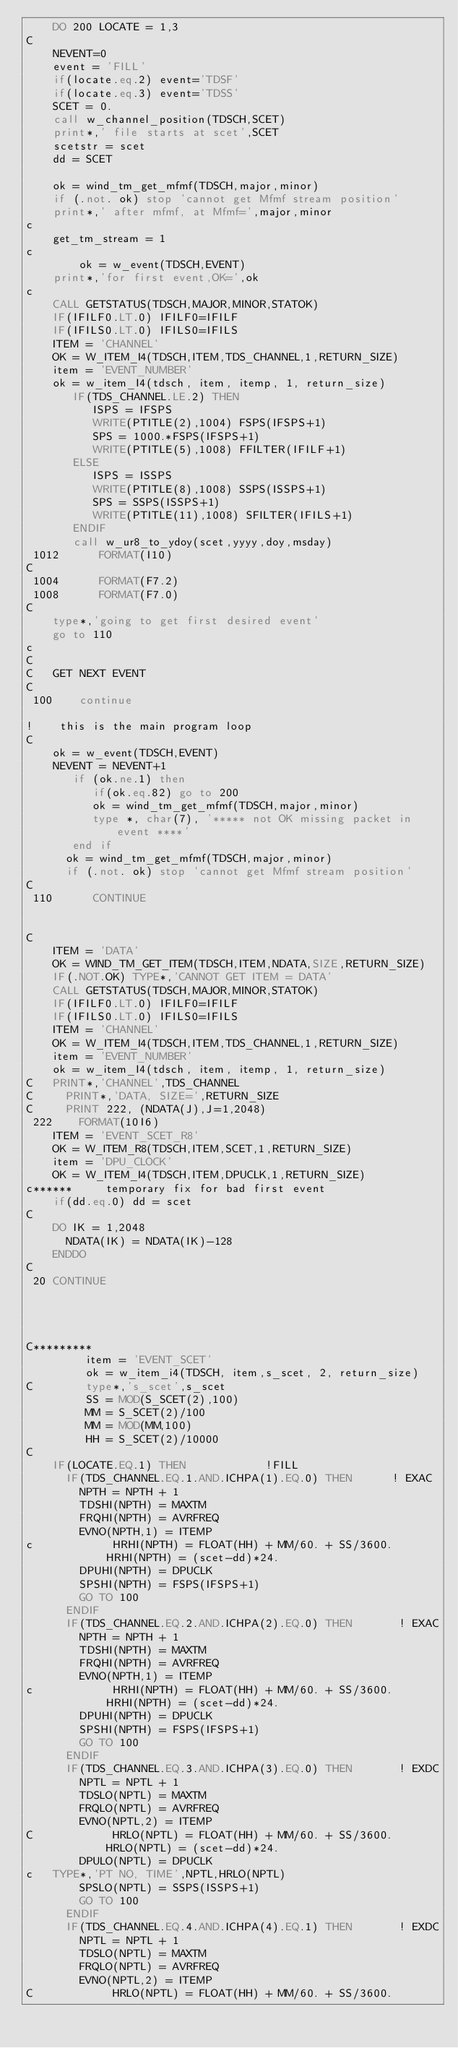Convert code to text. <code><loc_0><loc_0><loc_500><loc_500><_FORTRAN_>	DO 200 LOCATE = 1,3
C
	NEVENT=0
	event = 'FILL'
	if(locate.eq.2) event='TDSF'
	if(locate.eq.3) event='TDSS'
	SCET = 0.
	call w_channel_position(TDSCH,SCET)
	print*,' file starts at scet',SCET
	scetstr = scet
	dd = SCET

	ok = wind_tm_get_mfmf(TDSCH,major,minor)
	if (.not. ok) stop 'cannot get Mfmf stream position'
	print*,' after mfmf, at Mfmf=',major,minor
c
	get_tm_stream = 1
c
        ok = w_event(TDSCH,EVENT)
	print*,'for first event,OK=',ok
c
	CALL GETSTATUS(TDSCH,MAJOR,MINOR,STATOK)
	IF(IFILF0.LT.0) IFILF0=IFILF
	IF(IFILS0.LT.0) IFILS0=IFILS
	ITEM = 'CHANNEL'
	OK = W_ITEM_I4(TDSCH,ITEM,TDS_CHANNEL,1,RETURN_SIZE)
	item = 'EVENT_NUMBER'
	ok = w_item_I4(tdsch, item, itemp, 1, return_size)
	   IF(TDS_CHANNEL.LE.2) THEN
	      ISPS = IFSPS
	      WRITE(PTITLE(2),1004) FSPS(IFSPS+1)
	      SPS = 1000.*FSPS(IFSPS+1)
	      WRITE(PTITLE(5),1008) FFILTER(IFILF+1)
	   ELSE
	      ISPS = ISSPS
	      WRITE(PTITLE(8),1008) SSPS(ISSPS+1)
	      SPS = SSPS(ISSPS+1)
	      WRITE(PTITLE(11),1008) SFILTER(IFILS+1)
	   ENDIF
	   call w_ur8_to_ydoy(scet,yyyy,doy,msday)
 1012	   FORMAT(I10)
C
 1004	   FORMAT(F7.2)
 1008	   FORMAT(F7.0)
C
	type*,'going to get first desired event'
	go to 110
c
C
C	GET NEXT EVENT
C
 100    continue

!	 this is the main program loop
C
	ok = w_event(TDSCH,EVENT)
	NEVENT = NEVENT+1
	   if (ok.ne.1) then
	      if(ok.eq.82) go to 200
	      ok = wind_tm_get_mfmf(TDSCH,major,minor)
	      type *, char(7), '***** not OK missing packet in event ****'
	   end if
	  ok = wind_tm_get_mfmf(TDSCH,major,minor)
	  if (.not. ok) stop 'cannot get Mfmf stream position'
C
 110	  CONTINUE


C
	ITEM = 'DATA'
	OK = WIND_TM_GET_ITEM(TDSCH,ITEM,NDATA,SIZE,RETURN_SIZE)
	IF(.NOT.OK) TYPE*,'CANNOT GET ITEM = DATA'
	CALL GETSTATUS(TDSCH,MAJOR,MINOR,STATOK)
	IF(IFILF0.LT.0) IFILF0=IFILF
	IF(IFILS0.LT.0) IFILS0=IFILS
	ITEM = 'CHANNEL'
	OK = W_ITEM_I4(TDSCH,ITEM,TDS_CHANNEL,1,RETURN_SIZE)
	item = 'EVENT_NUMBER'
	ok = w_item_I4(tdsch, item, itemp, 1, return_size)
C	PRINT*,'CHANNEL',TDS_CHANNEL
C	  PRINT*,'DATA, SIZE=',RETURN_SIZE
C	  PRINT 222, (NDATA(J),J=1,2048)
 222	FORMAT(10I6)
	ITEM = 'EVENT_SCET_R8'
	OK = W_ITEM_R8(TDSCH,ITEM,SCET,1,RETURN_SIZE)
	item = 'DPU_CLOCK'
	OK = W_ITEM_I4(TDSCH,ITEM,DPUCLK,1,RETURN_SIZE)
c******		temporary fix for bad first event
	if(dd.eq.0) dd = scet
C
	DO IK = 1,2048
	  NDATA(IK) = NDATA(IK)-128
	ENDDO
C
 20	CONTINUE




C*********
	     item = 'EVENT_SCET'
	     ok = w_item_i4(TDSCH, item,s_scet, 2, return_size)
C	     type*,'s_scet',s_scet 
	     SS = MOD(S_SCET(2),100)
	     MM = S_SCET(2)/100
	     MM = MOD(MM,100)
	     HH = S_SCET(2)/10000
C
	IF(LOCATE.EQ.1) THEN			!FILL
	  IF(TDS_CHANNEL.EQ.1.AND.ICHPA(1).EQ.0) THEN      ! EXAC
	    NPTH = NPTH + 1
	    TDSHI(NPTH) = MAXTM
	    FRQHI(NPTH) = AVRFREQ
	    EVNO(NPTH,1) = ITEMP
c            HRHI(NPTH) = FLOAT(HH) + MM/60. + SS/3600.
            HRHI(NPTH) = (scet-dd)*24.
	    DPUHI(NPTH) = DPUCLK
	    SPSHI(NPTH) = FSPS(IFSPS+1)
	    GO TO 100
	  ENDIF
	  IF(TDS_CHANNEL.EQ.2.AND.ICHPA(2).EQ.0) THEN       ! EXAC
	    NPTH = NPTH + 1
	    TDSHI(NPTH) = MAXTM
	    FRQHI(NPTH) = AVRFREQ
	    EVNO(NPTH,1) = ITEMP
c            HRHI(NPTH) = FLOAT(HH) + MM/60. + SS/3600.
            HRHI(NPTH) = (scet-dd)*24.
	    DPUHI(NPTH) = DPUCLK
	    SPSHI(NPTH) = FSPS(IFSPS+1)
	    GO TO 100
	  ENDIF
	  IF(TDS_CHANNEL.EQ.3.AND.ICHPA(3).EQ.0) THEN       ! EXDC
	    NPTL = NPTL + 1
	    TDSLO(NPTL) = MAXTM
	    FRQLO(NPTL) = AVRFREQ
	    EVNO(NPTL,2) = ITEMP
C            HRLO(NPTL) = FLOAT(HH) + MM/60. + SS/3600.
            HRLO(NPTL) = (scet-dd)*24.
	    DPULO(NPTL) = DPUCLK
c	TYPE*,'PT NO, TIME',NPTL,HRLO(NPTL) 
	    SPSLO(NPTL) = SSPS(ISSPS+1)
	    GO TO 100
	  ENDIF
	  IF(TDS_CHANNEL.EQ.4.AND.ICHPA(4).EQ.1) THEN       ! EXDC
	    NPTL = NPTL + 1
	    TDSLO(NPTL) = MAXTM
	    FRQLO(NPTL) = AVRFREQ
	    EVNO(NPTL,2) = ITEMP
C            HRLO(NPTL) = FLOAT(HH) + MM/60. + SS/3600.</code> 